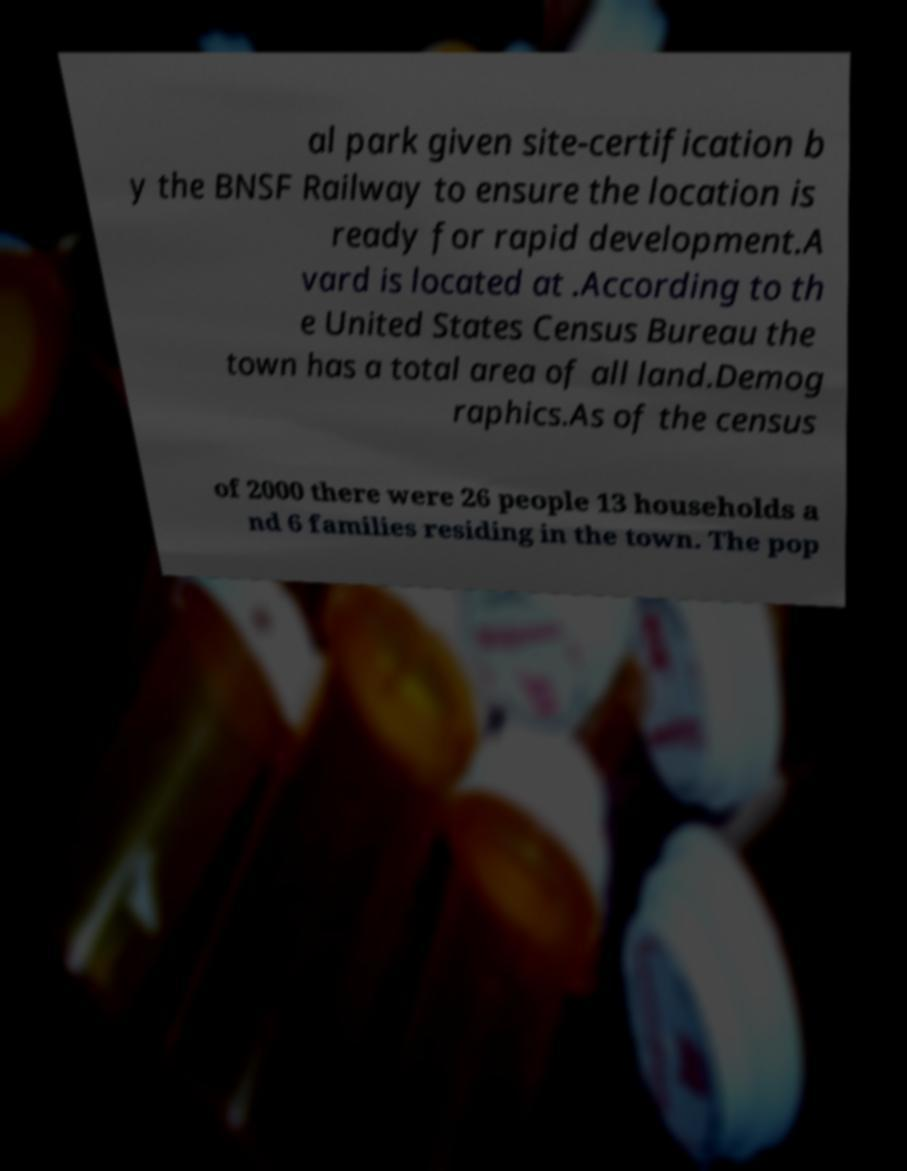Can you accurately transcribe the text from the provided image for me? al park given site-certification b y the BNSF Railway to ensure the location is ready for rapid development.A vard is located at .According to th e United States Census Bureau the town has a total area of all land.Demog raphics.As of the census of 2000 there were 26 people 13 households a nd 6 families residing in the town. The pop 